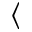<formula> <loc_0><loc_0><loc_500><loc_500>\langle</formula> 